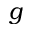Convert formula to latex. <formula><loc_0><loc_0><loc_500><loc_500>g</formula> 